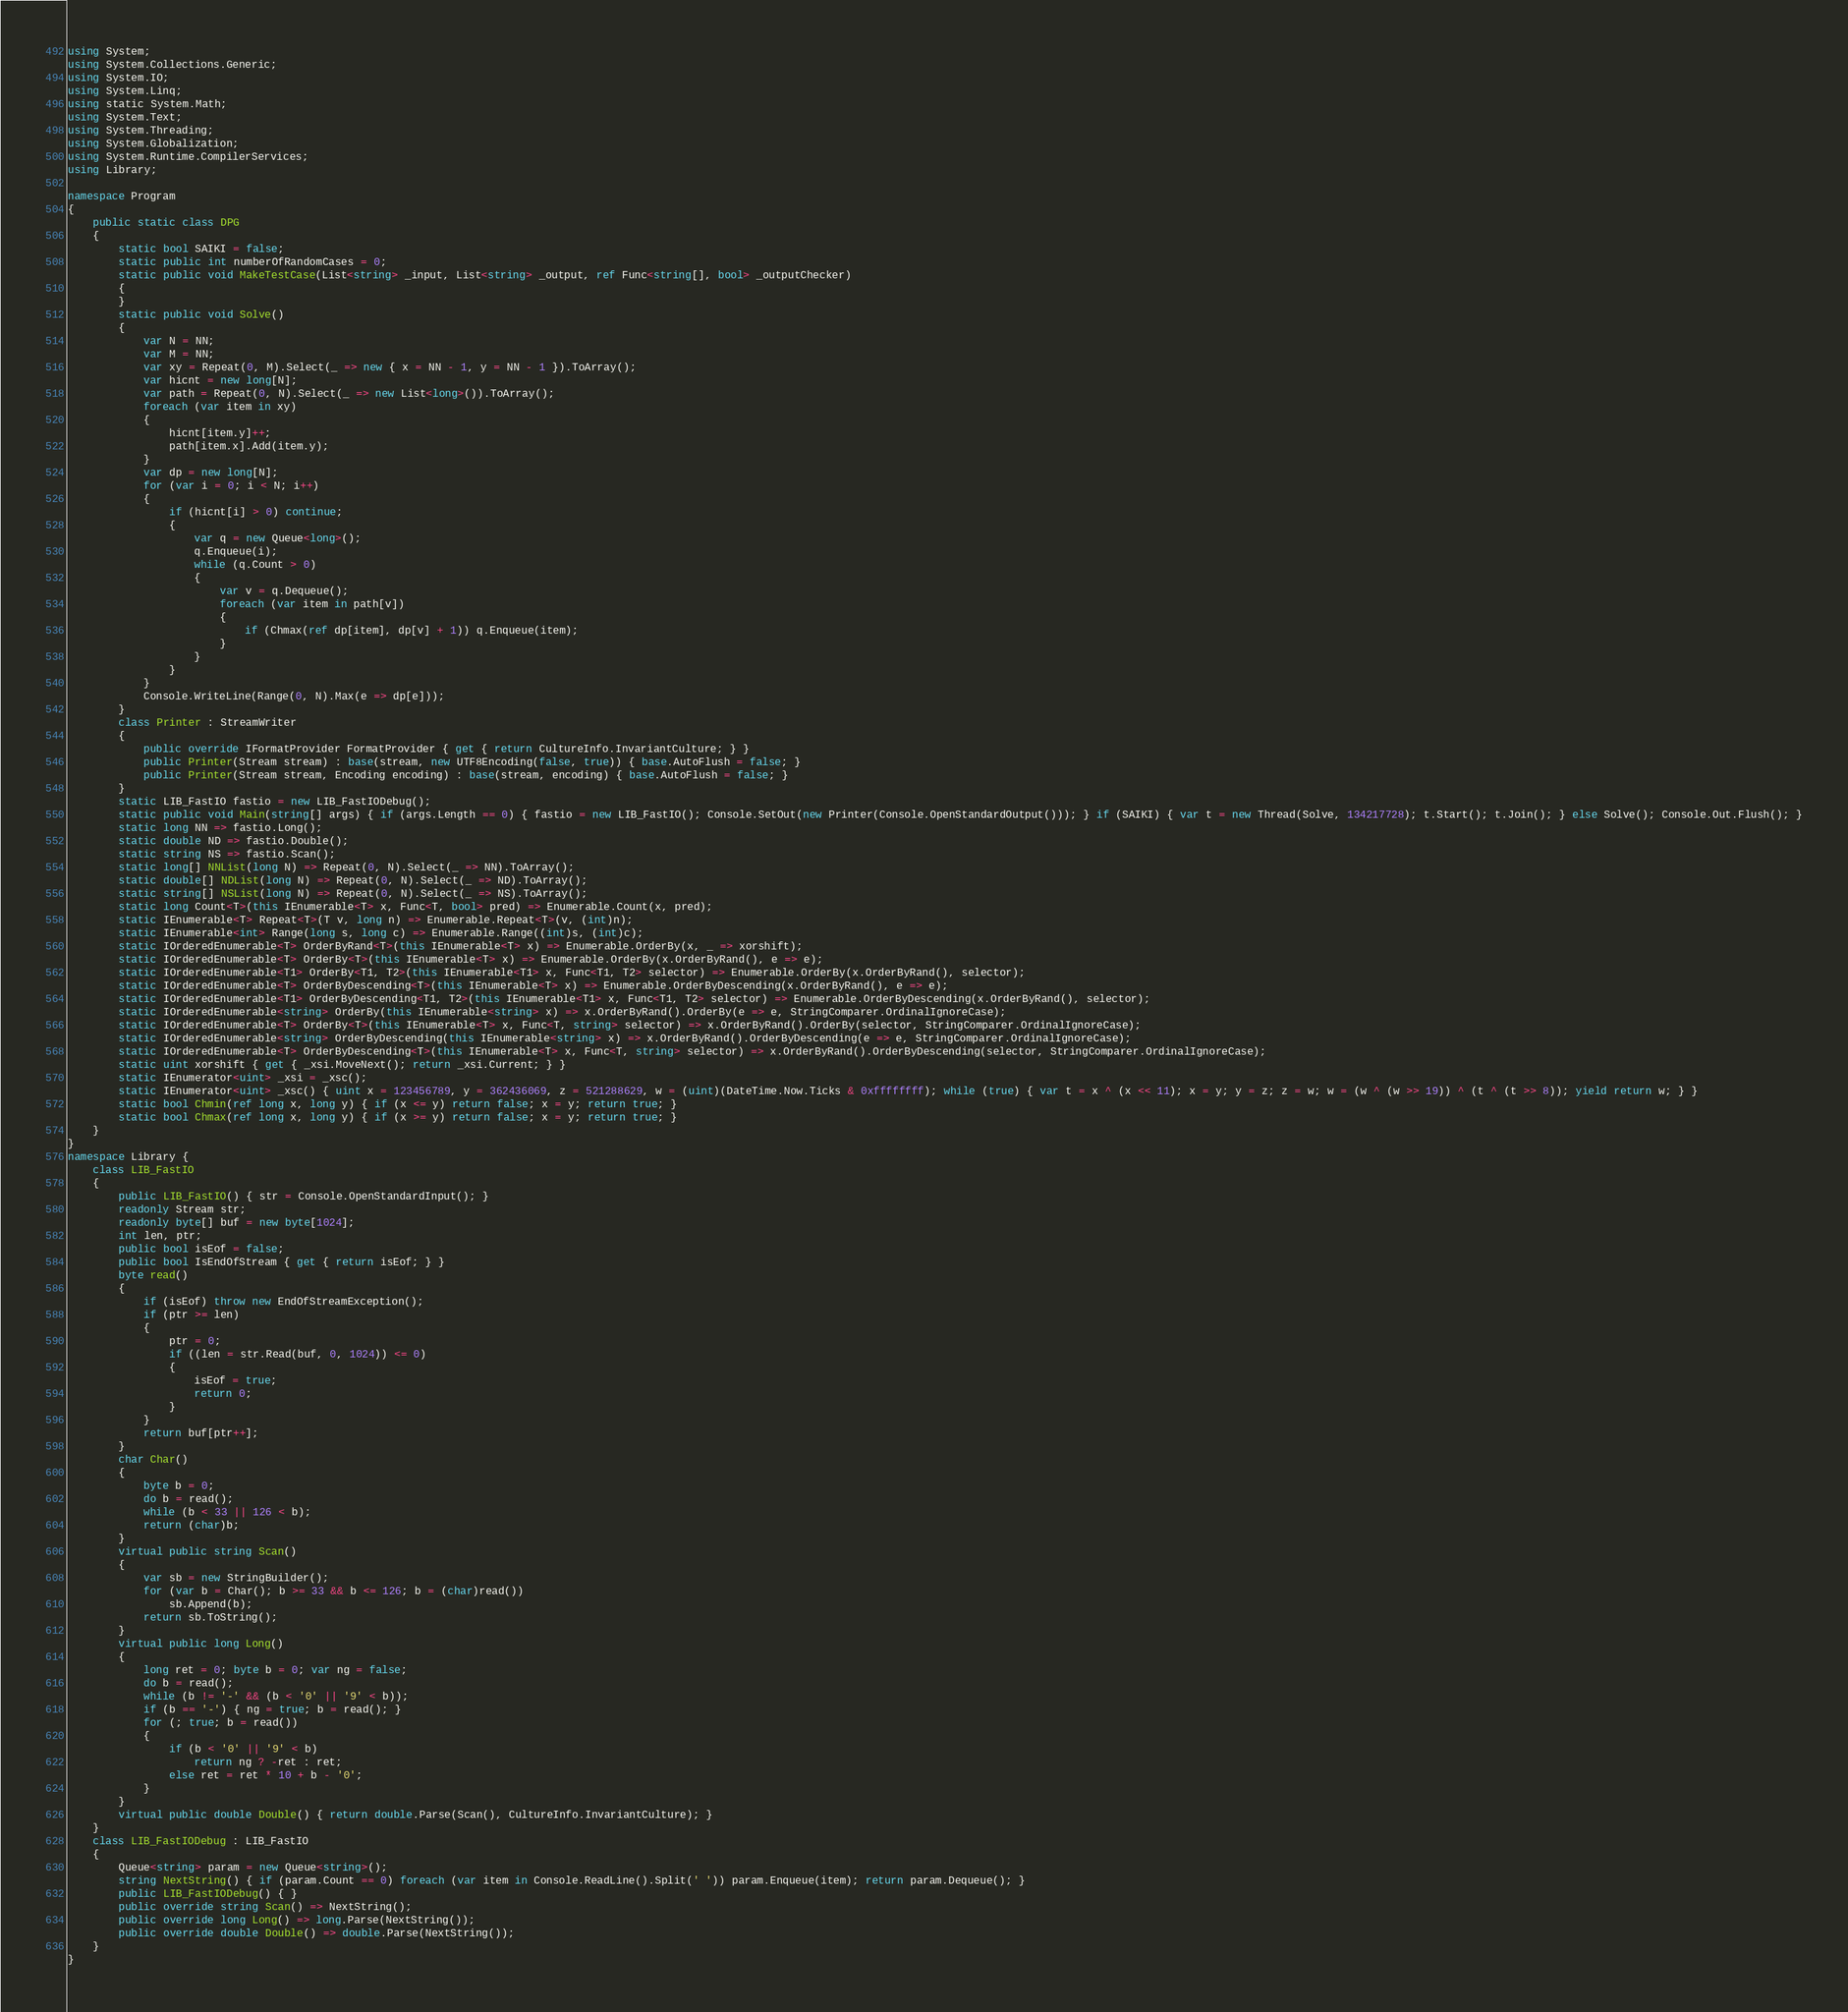<code> <loc_0><loc_0><loc_500><loc_500><_C#_>using System;
using System.Collections.Generic;
using System.IO;
using System.Linq;
using static System.Math;
using System.Text;
using System.Threading;
using System.Globalization;
using System.Runtime.CompilerServices;
using Library;

namespace Program
{
    public static class DPG
    {
        static bool SAIKI = false;
        static public int numberOfRandomCases = 0;
        static public void MakeTestCase(List<string> _input, List<string> _output, ref Func<string[], bool> _outputChecker)
        {
        }
        static public void Solve()
        {
            var N = NN;
            var M = NN;
            var xy = Repeat(0, M).Select(_ => new { x = NN - 1, y = NN - 1 }).ToArray();
            var hicnt = new long[N];
            var path = Repeat(0, N).Select(_ => new List<long>()).ToArray();
            foreach (var item in xy)
            {
                hicnt[item.y]++;
                path[item.x].Add(item.y);
            }
            var dp = new long[N];
            for (var i = 0; i < N; i++)
            {
                if (hicnt[i] > 0) continue;
                {
                    var q = new Queue<long>();
                    q.Enqueue(i);
                    while (q.Count > 0)
                    {
                        var v = q.Dequeue();
                        foreach (var item in path[v])
                        {
                            if (Chmax(ref dp[item], dp[v] + 1)) q.Enqueue(item);
                        }
                    }
                }
            }
            Console.WriteLine(Range(0, N).Max(e => dp[e]));
        }
        class Printer : StreamWriter
        {
            public override IFormatProvider FormatProvider { get { return CultureInfo.InvariantCulture; } }
            public Printer(Stream stream) : base(stream, new UTF8Encoding(false, true)) { base.AutoFlush = false; }
            public Printer(Stream stream, Encoding encoding) : base(stream, encoding) { base.AutoFlush = false; }
        }
        static LIB_FastIO fastio = new LIB_FastIODebug();
        static public void Main(string[] args) { if (args.Length == 0) { fastio = new LIB_FastIO(); Console.SetOut(new Printer(Console.OpenStandardOutput())); } if (SAIKI) { var t = new Thread(Solve, 134217728); t.Start(); t.Join(); } else Solve(); Console.Out.Flush(); }
        static long NN => fastio.Long();
        static double ND => fastio.Double();
        static string NS => fastio.Scan();
        static long[] NNList(long N) => Repeat(0, N).Select(_ => NN).ToArray();
        static double[] NDList(long N) => Repeat(0, N).Select(_ => ND).ToArray();
        static string[] NSList(long N) => Repeat(0, N).Select(_ => NS).ToArray();
        static long Count<T>(this IEnumerable<T> x, Func<T, bool> pred) => Enumerable.Count(x, pred);
        static IEnumerable<T> Repeat<T>(T v, long n) => Enumerable.Repeat<T>(v, (int)n);
        static IEnumerable<int> Range(long s, long c) => Enumerable.Range((int)s, (int)c);
        static IOrderedEnumerable<T> OrderByRand<T>(this IEnumerable<T> x) => Enumerable.OrderBy(x, _ => xorshift);
        static IOrderedEnumerable<T> OrderBy<T>(this IEnumerable<T> x) => Enumerable.OrderBy(x.OrderByRand(), e => e);
        static IOrderedEnumerable<T1> OrderBy<T1, T2>(this IEnumerable<T1> x, Func<T1, T2> selector) => Enumerable.OrderBy(x.OrderByRand(), selector);
        static IOrderedEnumerable<T> OrderByDescending<T>(this IEnumerable<T> x) => Enumerable.OrderByDescending(x.OrderByRand(), e => e);
        static IOrderedEnumerable<T1> OrderByDescending<T1, T2>(this IEnumerable<T1> x, Func<T1, T2> selector) => Enumerable.OrderByDescending(x.OrderByRand(), selector);
        static IOrderedEnumerable<string> OrderBy(this IEnumerable<string> x) => x.OrderByRand().OrderBy(e => e, StringComparer.OrdinalIgnoreCase);
        static IOrderedEnumerable<T> OrderBy<T>(this IEnumerable<T> x, Func<T, string> selector) => x.OrderByRand().OrderBy(selector, StringComparer.OrdinalIgnoreCase);
        static IOrderedEnumerable<string> OrderByDescending(this IEnumerable<string> x) => x.OrderByRand().OrderByDescending(e => e, StringComparer.OrdinalIgnoreCase);
        static IOrderedEnumerable<T> OrderByDescending<T>(this IEnumerable<T> x, Func<T, string> selector) => x.OrderByRand().OrderByDescending(selector, StringComparer.OrdinalIgnoreCase);
        static uint xorshift { get { _xsi.MoveNext(); return _xsi.Current; } }
        static IEnumerator<uint> _xsi = _xsc();
        static IEnumerator<uint> _xsc() { uint x = 123456789, y = 362436069, z = 521288629, w = (uint)(DateTime.Now.Ticks & 0xffffffff); while (true) { var t = x ^ (x << 11); x = y; y = z; z = w; w = (w ^ (w >> 19)) ^ (t ^ (t >> 8)); yield return w; } }
        static bool Chmin(ref long x, long y) { if (x <= y) return false; x = y; return true; }
        static bool Chmax(ref long x, long y) { if (x >= y) return false; x = y; return true; }
    }
}
namespace Library {
    class LIB_FastIO
    {
        public LIB_FastIO() { str = Console.OpenStandardInput(); }
        readonly Stream str;
        readonly byte[] buf = new byte[1024];
        int len, ptr;
        public bool isEof = false;
        public bool IsEndOfStream { get { return isEof; } }
        byte read()
        {
            if (isEof) throw new EndOfStreamException();
            if (ptr >= len)
            {
                ptr = 0;
                if ((len = str.Read(buf, 0, 1024)) <= 0)
                {
                    isEof = true;
                    return 0;
                }
            }
            return buf[ptr++];
        }
        char Char()
        {
            byte b = 0;
            do b = read();
            while (b < 33 || 126 < b);
            return (char)b;
        }
        virtual public string Scan()
        {
            var sb = new StringBuilder();
            for (var b = Char(); b >= 33 && b <= 126; b = (char)read())
                sb.Append(b);
            return sb.ToString();
        }
        virtual public long Long()
        {
            long ret = 0; byte b = 0; var ng = false;
            do b = read();
            while (b != '-' && (b < '0' || '9' < b));
            if (b == '-') { ng = true; b = read(); }
            for (; true; b = read())
            {
                if (b < '0' || '9' < b)
                    return ng ? -ret : ret;
                else ret = ret * 10 + b - '0';
            }
        }
        virtual public double Double() { return double.Parse(Scan(), CultureInfo.InvariantCulture); }
    }
    class LIB_FastIODebug : LIB_FastIO
    {
        Queue<string> param = new Queue<string>();
        string NextString() { if (param.Count == 0) foreach (var item in Console.ReadLine().Split(' ')) param.Enqueue(item); return param.Dequeue(); }
        public LIB_FastIODebug() { }
        public override string Scan() => NextString();
        public override long Long() => long.Parse(NextString());
        public override double Double() => double.Parse(NextString());
    }
}
</code> 